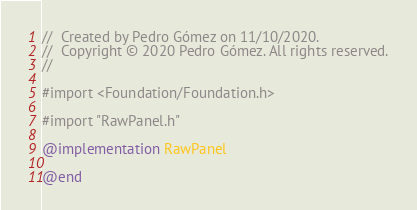<code> <loc_0><loc_0><loc_500><loc_500><_ObjectiveC_>//  Created by Pedro Gómez on 11/10/2020.
//  Copyright © 2020 Pedro Gómez. All rights reserved.
//

#import <Foundation/Foundation.h>

#import "RawPanel.h"

@implementation RawPanel

@end
</code> 